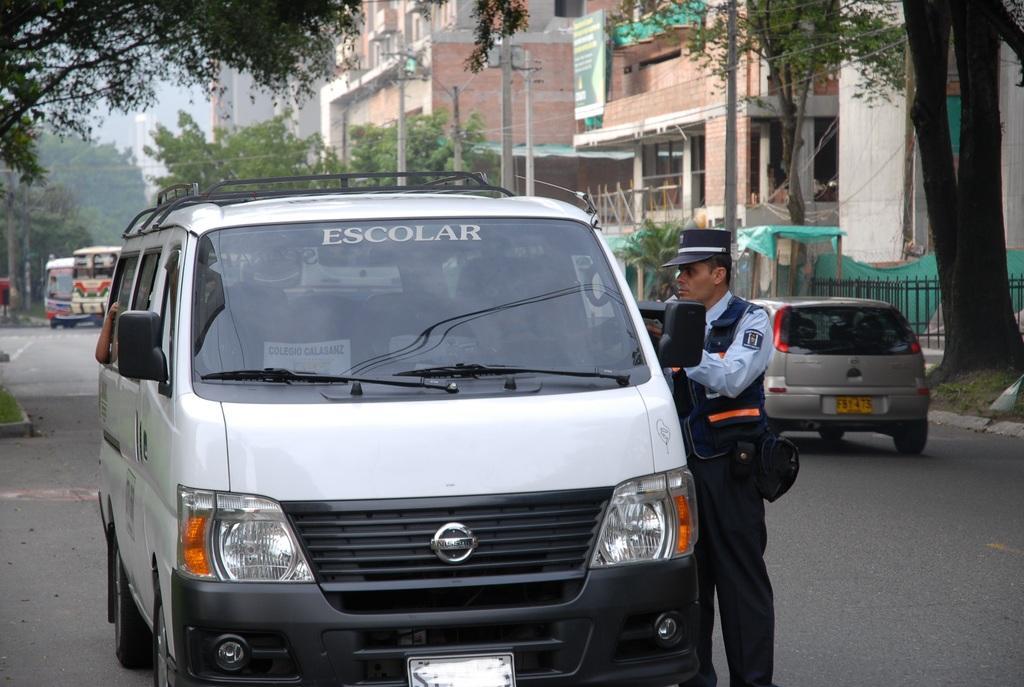Describe this image in one or two sentences. We can able to see a white van. Beside this van a police person is standing. He wore police cap and police uniform. On road vehicles are travelling. Far there are number of trees. Buildings are made with bricks and it is in red color. Poles are far away from each other. 